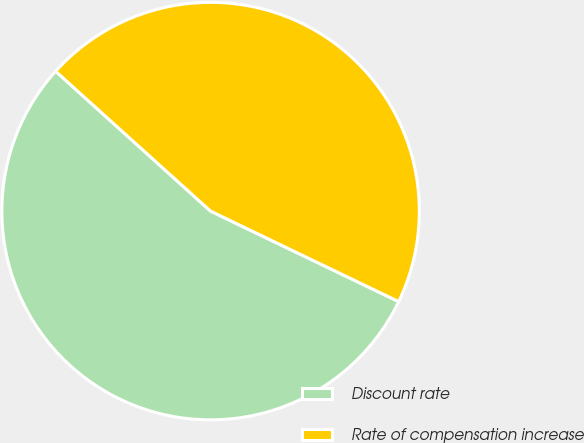<chart> <loc_0><loc_0><loc_500><loc_500><pie_chart><fcel>Discount rate<fcel>Rate of compensation increase<nl><fcel>54.55%<fcel>45.45%<nl></chart> 